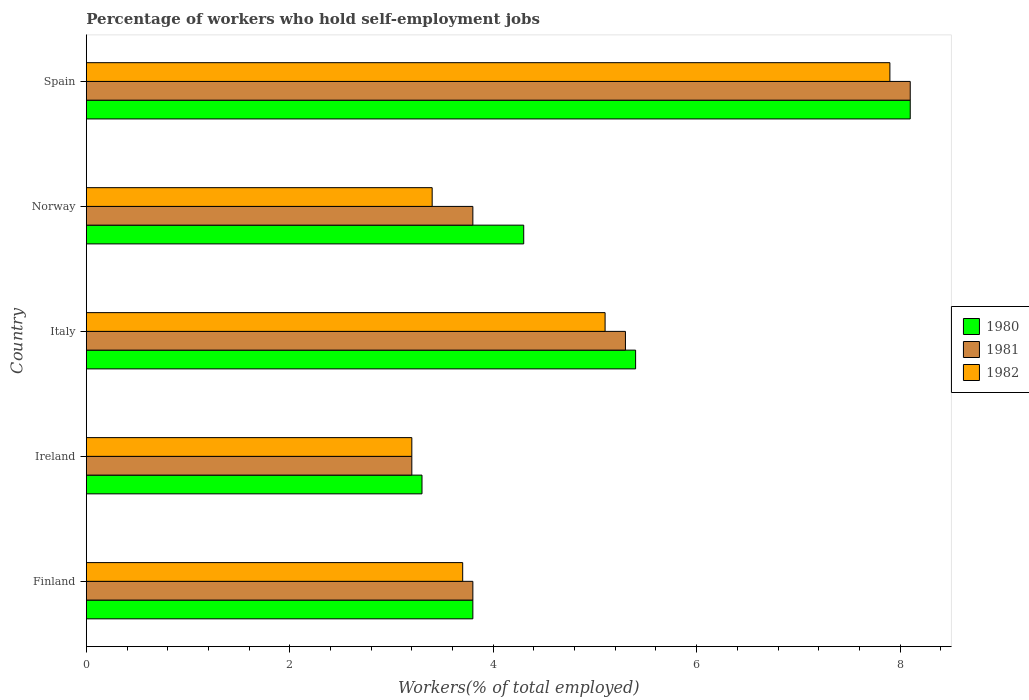How many different coloured bars are there?
Ensure brevity in your answer.  3. How many groups of bars are there?
Offer a very short reply. 5. How many bars are there on the 3rd tick from the bottom?
Your answer should be compact. 3. What is the label of the 1st group of bars from the top?
Offer a terse response. Spain. In how many cases, is the number of bars for a given country not equal to the number of legend labels?
Offer a terse response. 0. What is the percentage of self-employed workers in 1980 in Norway?
Offer a very short reply. 4.3. Across all countries, what is the maximum percentage of self-employed workers in 1981?
Your answer should be very brief. 8.1. Across all countries, what is the minimum percentage of self-employed workers in 1981?
Your answer should be compact. 3.2. In which country was the percentage of self-employed workers in 1982 maximum?
Provide a short and direct response. Spain. In which country was the percentage of self-employed workers in 1982 minimum?
Keep it short and to the point. Ireland. What is the total percentage of self-employed workers in 1981 in the graph?
Offer a very short reply. 24.2. What is the difference between the percentage of self-employed workers in 1980 in Ireland and that in Italy?
Make the answer very short. -2.1. What is the difference between the percentage of self-employed workers in 1980 in Spain and the percentage of self-employed workers in 1982 in Norway?
Make the answer very short. 4.7. What is the average percentage of self-employed workers in 1981 per country?
Provide a succinct answer. 4.84. What is the difference between the percentage of self-employed workers in 1980 and percentage of self-employed workers in 1982 in Finland?
Offer a terse response. 0.1. In how many countries, is the percentage of self-employed workers in 1980 greater than 8 %?
Make the answer very short. 1. What is the ratio of the percentage of self-employed workers in 1981 in Italy to that in Spain?
Provide a succinct answer. 0.65. Is the percentage of self-employed workers in 1980 in Italy less than that in Spain?
Your response must be concise. Yes. What is the difference between the highest and the second highest percentage of self-employed workers in 1982?
Provide a succinct answer. 2.8. What is the difference between the highest and the lowest percentage of self-employed workers in 1980?
Provide a short and direct response. 4.8. In how many countries, is the percentage of self-employed workers in 1981 greater than the average percentage of self-employed workers in 1981 taken over all countries?
Offer a very short reply. 2. What does the 3rd bar from the top in Spain represents?
Offer a terse response. 1980. Is it the case that in every country, the sum of the percentage of self-employed workers in 1982 and percentage of self-employed workers in 1981 is greater than the percentage of self-employed workers in 1980?
Ensure brevity in your answer.  Yes. How many bars are there?
Your response must be concise. 15. What is the difference between two consecutive major ticks on the X-axis?
Ensure brevity in your answer.  2. Does the graph contain any zero values?
Offer a very short reply. No. Does the graph contain grids?
Provide a short and direct response. No. What is the title of the graph?
Offer a terse response. Percentage of workers who hold self-employment jobs. What is the label or title of the X-axis?
Keep it short and to the point. Workers(% of total employed). What is the Workers(% of total employed) of 1980 in Finland?
Your answer should be compact. 3.8. What is the Workers(% of total employed) in 1981 in Finland?
Offer a terse response. 3.8. What is the Workers(% of total employed) in 1982 in Finland?
Provide a short and direct response. 3.7. What is the Workers(% of total employed) in 1980 in Ireland?
Your answer should be compact. 3.3. What is the Workers(% of total employed) of 1981 in Ireland?
Provide a short and direct response. 3.2. What is the Workers(% of total employed) of 1982 in Ireland?
Keep it short and to the point. 3.2. What is the Workers(% of total employed) in 1980 in Italy?
Your answer should be compact. 5.4. What is the Workers(% of total employed) in 1981 in Italy?
Offer a terse response. 5.3. What is the Workers(% of total employed) of 1982 in Italy?
Provide a succinct answer. 5.1. What is the Workers(% of total employed) in 1980 in Norway?
Provide a short and direct response. 4.3. What is the Workers(% of total employed) of 1981 in Norway?
Your answer should be compact. 3.8. What is the Workers(% of total employed) in 1982 in Norway?
Keep it short and to the point. 3.4. What is the Workers(% of total employed) of 1980 in Spain?
Make the answer very short. 8.1. What is the Workers(% of total employed) of 1981 in Spain?
Offer a terse response. 8.1. What is the Workers(% of total employed) of 1982 in Spain?
Your response must be concise. 7.9. Across all countries, what is the maximum Workers(% of total employed) in 1980?
Your answer should be very brief. 8.1. Across all countries, what is the maximum Workers(% of total employed) of 1981?
Provide a succinct answer. 8.1. Across all countries, what is the maximum Workers(% of total employed) in 1982?
Give a very brief answer. 7.9. Across all countries, what is the minimum Workers(% of total employed) in 1980?
Offer a very short reply. 3.3. Across all countries, what is the minimum Workers(% of total employed) of 1981?
Ensure brevity in your answer.  3.2. Across all countries, what is the minimum Workers(% of total employed) of 1982?
Provide a succinct answer. 3.2. What is the total Workers(% of total employed) of 1980 in the graph?
Offer a terse response. 24.9. What is the total Workers(% of total employed) of 1981 in the graph?
Your response must be concise. 24.2. What is the total Workers(% of total employed) of 1982 in the graph?
Offer a terse response. 23.3. What is the difference between the Workers(% of total employed) in 1980 in Finland and that in Ireland?
Give a very brief answer. 0.5. What is the difference between the Workers(% of total employed) in 1981 in Finland and that in Ireland?
Your answer should be very brief. 0.6. What is the difference between the Workers(% of total employed) of 1982 in Finland and that in Ireland?
Ensure brevity in your answer.  0.5. What is the difference between the Workers(% of total employed) of 1980 in Finland and that in Norway?
Provide a short and direct response. -0.5. What is the difference between the Workers(% of total employed) of 1981 in Finland and that in Norway?
Keep it short and to the point. 0. What is the difference between the Workers(% of total employed) of 1980 in Finland and that in Spain?
Offer a terse response. -4.3. What is the difference between the Workers(% of total employed) in 1980 in Ireland and that in Italy?
Your answer should be compact. -2.1. What is the difference between the Workers(% of total employed) of 1981 in Ireland and that in Norway?
Offer a very short reply. -0.6. What is the difference between the Workers(% of total employed) of 1980 in Ireland and that in Spain?
Make the answer very short. -4.8. What is the difference between the Workers(% of total employed) in 1981 in Ireland and that in Spain?
Your answer should be compact. -4.9. What is the difference between the Workers(% of total employed) of 1982 in Ireland and that in Spain?
Provide a short and direct response. -4.7. What is the difference between the Workers(% of total employed) of 1980 in Italy and that in Norway?
Provide a short and direct response. 1.1. What is the difference between the Workers(% of total employed) in 1981 in Italy and that in Norway?
Your answer should be compact. 1.5. What is the difference between the Workers(% of total employed) of 1982 in Italy and that in Norway?
Your answer should be very brief. 1.7. What is the difference between the Workers(% of total employed) of 1980 in Italy and that in Spain?
Your response must be concise. -2.7. What is the difference between the Workers(% of total employed) of 1981 in Italy and that in Spain?
Your response must be concise. -2.8. What is the difference between the Workers(% of total employed) in 1982 in Italy and that in Spain?
Your answer should be compact. -2.8. What is the difference between the Workers(% of total employed) in 1980 in Norway and that in Spain?
Provide a succinct answer. -3.8. What is the difference between the Workers(% of total employed) of 1982 in Norway and that in Spain?
Your response must be concise. -4.5. What is the difference between the Workers(% of total employed) in 1980 in Finland and the Workers(% of total employed) in 1982 in Norway?
Keep it short and to the point. 0.4. What is the difference between the Workers(% of total employed) of 1981 in Finland and the Workers(% of total employed) of 1982 in Norway?
Your answer should be very brief. 0.4. What is the difference between the Workers(% of total employed) of 1981 in Ireland and the Workers(% of total employed) of 1982 in Italy?
Keep it short and to the point. -1.9. What is the difference between the Workers(% of total employed) of 1980 in Ireland and the Workers(% of total employed) of 1981 in Norway?
Provide a short and direct response. -0.5. What is the difference between the Workers(% of total employed) in 1980 in Ireland and the Workers(% of total employed) in 1982 in Norway?
Your answer should be very brief. -0.1. What is the difference between the Workers(% of total employed) of 1980 in Ireland and the Workers(% of total employed) of 1981 in Spain?
Offer a very short reply. -4.8. What is the difference between the Workers(% of total employed) in 1981 in Ireland and the Workers(% of total employed) in 1982 in Spain?
Provide a short and direct response. -4.7. What is the difference between the Workers(% of total employed) of 1980 in Italy and the Workers(% of total employed) of 1981 in Spain?
Your answer should be very brief. -2.7. What is the difference between the Workers(% of total employed) of 1980 in Italy and the Workers(% of total employed) of 1982 in Spain?
Ensure brevity in your answer.  -2.5. What is the difference between the Workers(% of total employed) in 1981 in Italy and the Workers(% of total employed) in 1982 in Spain?
Your answer should be very brief. -2.6. What is the difference between the Workers(% of total employed) in 1980 in Norway and the Workers(% of total employed) in 1982 in Spain?
Your answer should be very brief. -3.6. What is the average Workers(% of total employed) in 1980 per country?
Offer a very short reply. 4.98. What is the average Workers(% of total employed) of 1981 per country?
Keep it short and to the point. 4.84. What is the average Workers(% of total employed) of 1982 per country?
Keep it short and to the point. 4.66. What is the difference between the Workers(% of total employed) in 1980 and Workers(% of total employed) in 1981 in Ireland?
Offer a very short reply. 0.1. What is the difference between the Workers(% of total employed) of 1981 and Workers(% of total employed) of 1982 in Ireland?
Provide a succinct answer. 0. What is the difference between the Workers(% of total employed) in 1980 and Workers(% of total employed) in 1981 in Italy?
Offer a terse response. 0.1. What is the difference between the Workers(% of total employed) in 1980 and Workers(% of total employed) in 1982 in Italy?
Ensure brevity in your answer.  0.3. What is the difference between the Workers(% of total employed) of 1981 and Workers(% of total employed) of 1982 in Italy?
Keep it short and to the point. 0.2. What is the difference between the Workers(% of total employed) of 1980 and Workers(% of total employed) of 1981 in Norway?
Provide a succinct answer. 0.5. What is the difference between the Workers(% of total employed) of 1981 and Workers(% of total employed) of 1982 in Norway?
Your response must be concise. 0.4. What is the difference between the Workers(% of total employed) of 1981 and Workers(% of total employed) of 1982 in Spain?
Keep it short and to the point. 0.2. What is the ratio of the Workers(% of total employed) in 1980 in Finland to that in Ireland?
Make the answer very short. 1.15. What is the ratio of the Workers(% of total employed) in 1981 in Finland to that in Ireland?
Your answer should be compact. 1.19. What is the ratio of the Workers(% of total employed) of 1982 in Finland to that in Ireland?
Keep it short and to the point. 1.16. What is the ratio of the Workers(% of total employed) of 1980 in Finland to that in Italy?
Make the answer very short. 0.7. What is the ratio of the Workers(% of total employed) of 1981 in Finland to that in Italy?
Offer a very short reply. 0.72. What is the ratio of the Workers(% of total employed) in 1982 in Finland to that in Italy?
Offer a terse response. 0.73. What is the ratio of the Workers(% of total employed) in 1980 in Finland to that in Norway?
Ensure brevity in your answer.  0.88. What is the ratio of the Workers(% of total employed) in 1982 in Finland to that in Norway?
Provide a succinct answer. 1.09. What is the ratio of the Workers(% of total employed) of 1980 in Finland to that in Spain?
Provide a short and direct response. 0.47. What is the ratio of the Workers(% of total employed) in 1981 in Finland to that in Spain?
Your answer should be compact. 0.47. What is the ratio of the Workers(% of total employed) of 1982 in Finland to that in Spain?
Ensure brevity in your answer.  0.47. What is the ratio of the Workers(% of total employed) of 1980 in Ireland to that in Italy?
Offer a terse response. 0.61. What is the ratio of the Workers(% of total employed) in 1981 in Ireland to that in Italy?
Keep it short and to the point. 0.6. What is the ratio of the Workers(% of total employed) of 1982 in Ireland to that in Italy?
Your response must be concise. 0.63. What is the ratio of the Workers(% of total employed) in 1980 in Ireland to that in Norway?
Offer a terse response. 0.77. What is the ratio of the Workers(% of total employed) of 1981 in Ireland to that in Norway?
Provide a short and direct response. 0.84. What is the ratio of the Workers(% of total employed) in 1982 in Ireland to that in Norway?
Give a very brief answer. 0.94. What is the ratio of the Workers(% of total employed) in 1980 in Ireland to that in Spain?
Offer a very short reply. 0.41. What is the ratio of the Workers(% of total employed) in 1981 in Ireland to that in Spain?
Your answer should be compact. 0.4. What is the ratio of the Workers(% of total employed) in 1982 in Ireland to that in Spain?
Provide a succinct answer. 0.41. What is the ratio of the Workers(% of total employed) of 1980 in Italy to that in Norway?
Make the answer very short. 1.26. What is the ratio of the Workers(% of total employed) in 1981 in Italy to that in Norway?
Offer a very short reply. 1.39. What is the ratio of the Workers(% of total employed) in 1982 in Italy to that in Norway?
Make the answer very short. 1.5. What is the ratio of the Workers(% of total employed) in 1981 in Italy to that in Spain?
Ensure brevity in your answer.  0.65. What is the ratio of the Workers(% of total employed) in 1982 in Italy to that in Spain?
Your response must be concise. 0.65. What is the ratio of the Workers(% of total employed) in 1980 in Norway to that in Spain?
Offer a terse response. 0.53. What is the ratio of the Workers(% of total employed) in 1981 in Norway to that in Spain?
Keep it short and to the point. 0.47. What is the ratio of the Workers(% of total employed) in 1982 in Norway to that in Spain?
Make the answer very short. 0.43. What is the difference between the highest and the second highest Workers(% of total employed) of 1980?
Make the answer very short. 2.7. What is the difference between the highest and the lowest Workers(% of total employed) of 1980?
Keep it short and to the point. 4.8. 